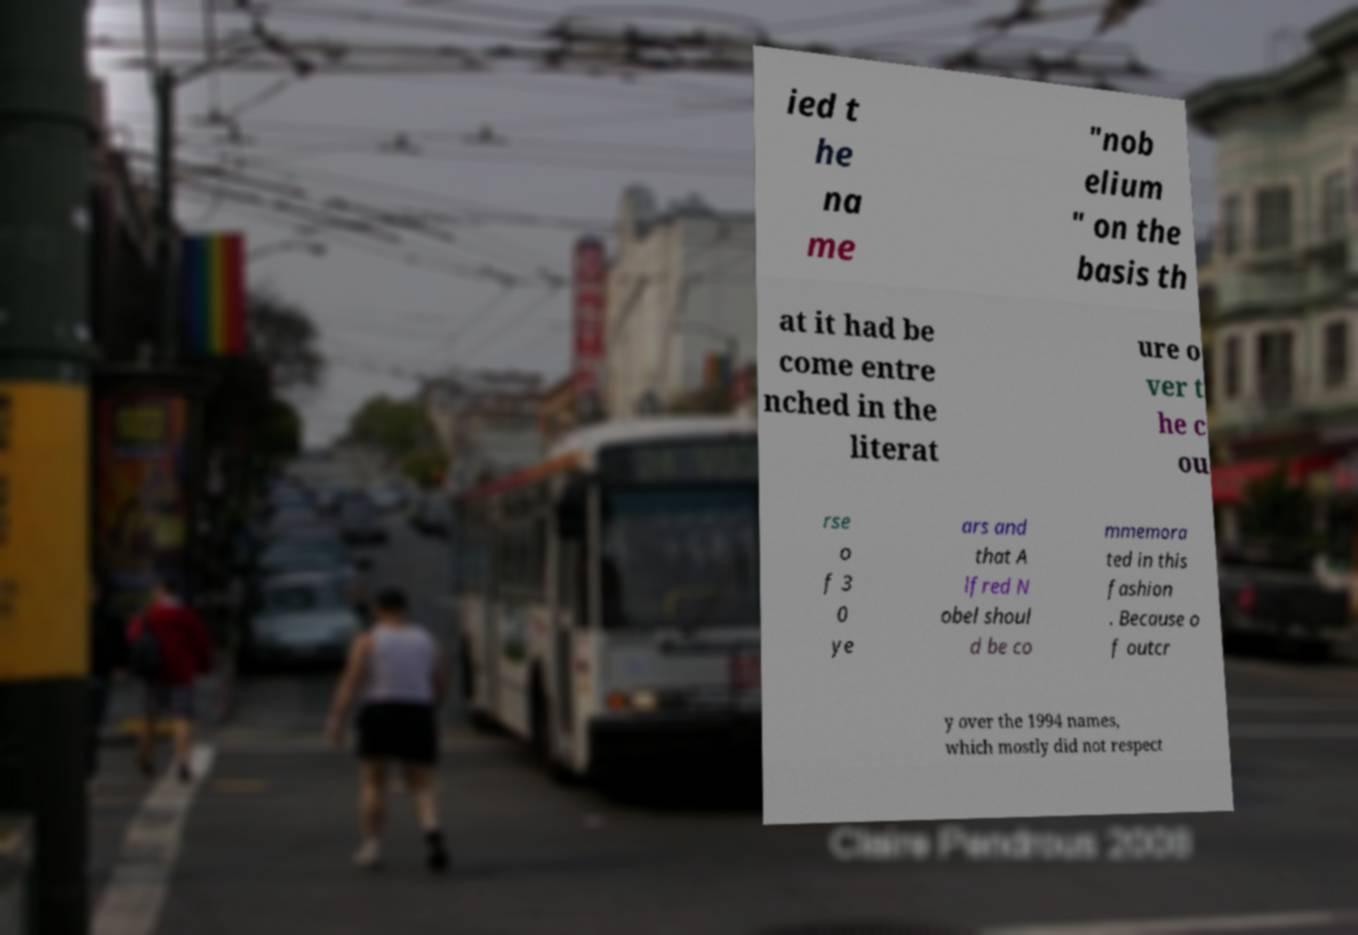I need the written content from this picture converted into text. Can you do that? ied t he na me "nob elium " on the basis th at it had be come entre nched in the literat ure o ver t he c ou rse o f 3 0 ye ars and that A lfred N obel shoul d be co mmemora ted in this fashion . Because o f outcr y over the 1994 names, which mostly did not respect 